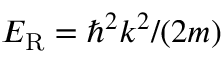Convert formula to latex. <formula><loc_0><loc_0><loc_500><loc_500>E _ { R } = \hbar { ^ } { 2 } k ^ { 2 } / ( 2 m )</formula> 